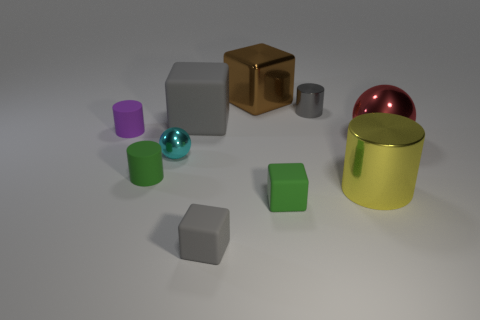Subtract all blocks. How many objects are left? 6 Subtract 0 brown spheres. How many objects are left? 10 Subtract all large yellow metallic cylinders. Subtract all tiny metal spheres. How many objects are left? 8 Add 7 metallic spheres. How many metallic spheres are left? 9 Add 4 large shiny cylinders. How many large shiny cylinders exist? 5 